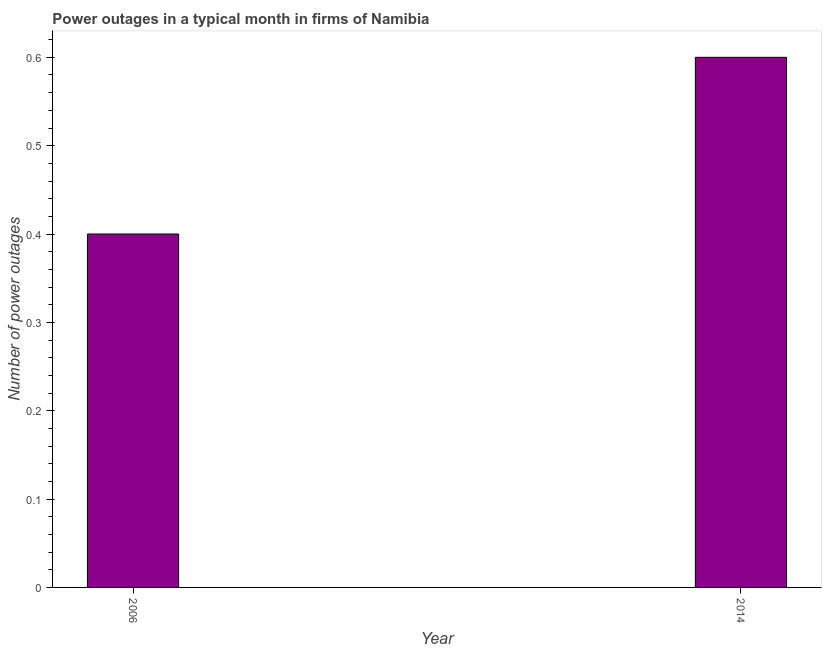Does the graph contain grids?
Ensure brevity in your answer.  No. What is the title of the graph?
Your answer should be compact. Power outages in a typical month in firms of Namibia. What is the label or title of the Y-axis?
Offer a terse response. Number of power outages. What is the number of power outages in 2006?
Offer a terse response. 0.4. Across all years, what is the maximum number of power outages?
Provide a short and direct response. 0.6. Across all years, what is the minimum number of power outages?
Your answer should be very brief. 0.4. What is the difference between the number of power outages in 2006 and 2014?
Ensure brevity in your answer.  -0.2. What is the average number of power outages per year?
Offer a terse response. 0.5. What is the ratio of the number of power outages in 2006 to that in 2014?
Ensure brevity in your answer.  0.67. Is the number of power outages in 2006 less than that in 2014?
Offer a terse response. Yes. In how many years, is the number of power outages greater than the average number of power outages taken over all years?
Ensure brevity in your answer.  1. How many bars are there?
Give a very brief answer. 2. How many years are there in the graph?
Your answer should be compact. 2. Are the values on the major ticks of Y-axis written in scientific E-notation?
Provide a succinct answer. No. What is the ratio of the Number of power outages in 2006 to that in 2014?
Offer a terse response. 0.67. 